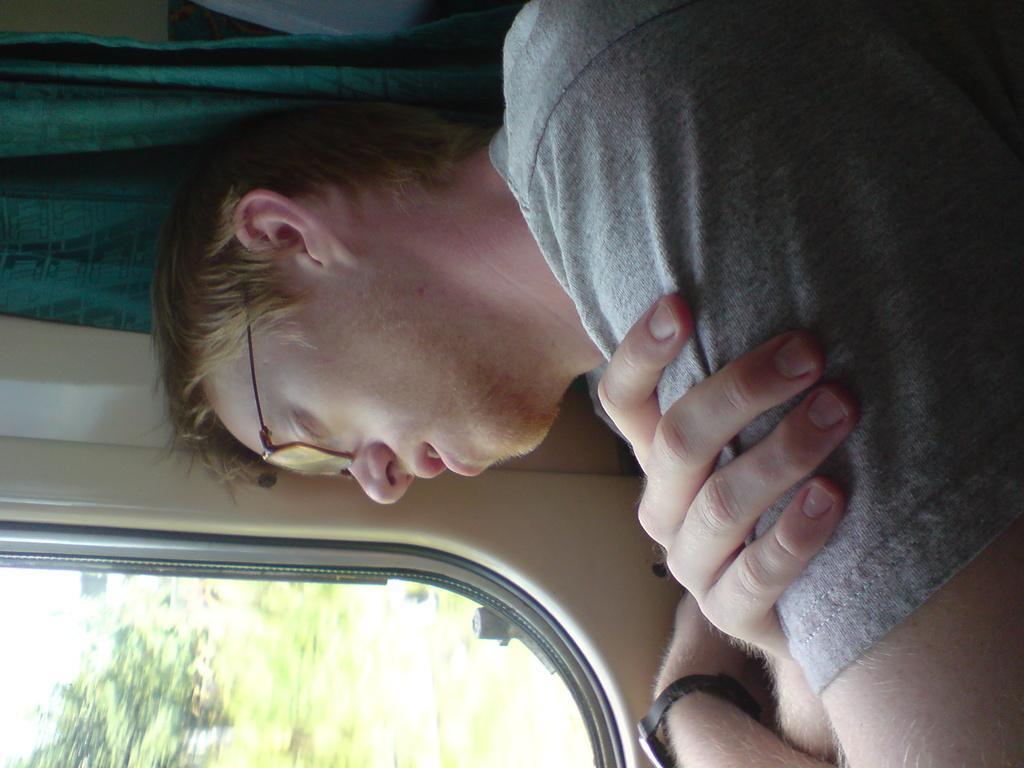Can you describe this image briefly? In the image there is a person sitting beside the window and sleeping. He is laying his head towards the window. 